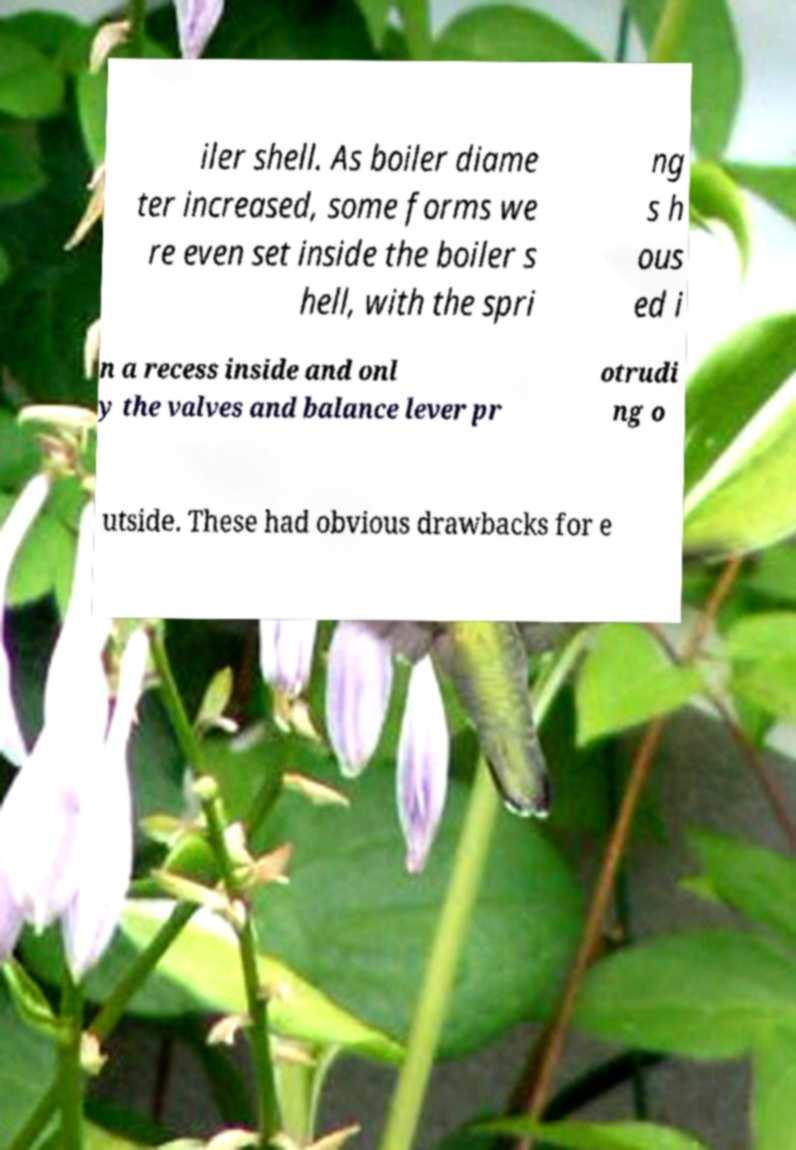I need the written content from this picture converted into text. Can you do that? iler shell. As boiler diame ter increased, some forms we re even set inside the boiler s hell, with the spri ng s h ous ed i n a recess inside and onl y the valves and balance lever pr otrudi ng o utside. These had obvious drawbacks for e 